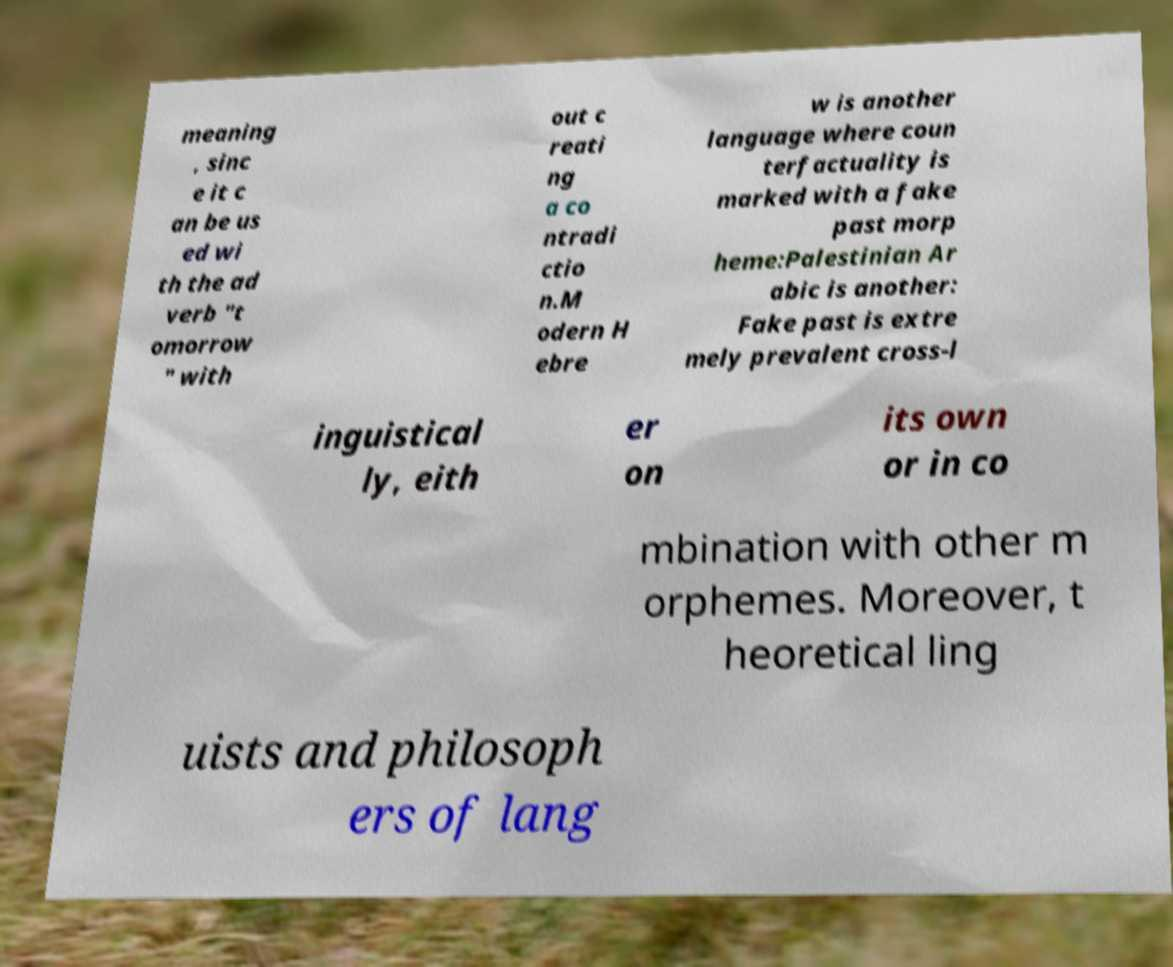Can you accurately transcribe the text from the provided image for me? meaning , sinc e it c an be us ed wi th the ad verb "t omorrow " with out c reati ng a co ntradi ctio n.M odern H ebre w is another language where coun terfactuality is marked with a fake past morp heme:Palestinian Ar abic is another: Fake past is extre mely prevalent cross-l inguistical ly, eith er on its own or in co mbination with other m orphemes. Moreover, t heoretical ling uists and philosoph ers of lang 